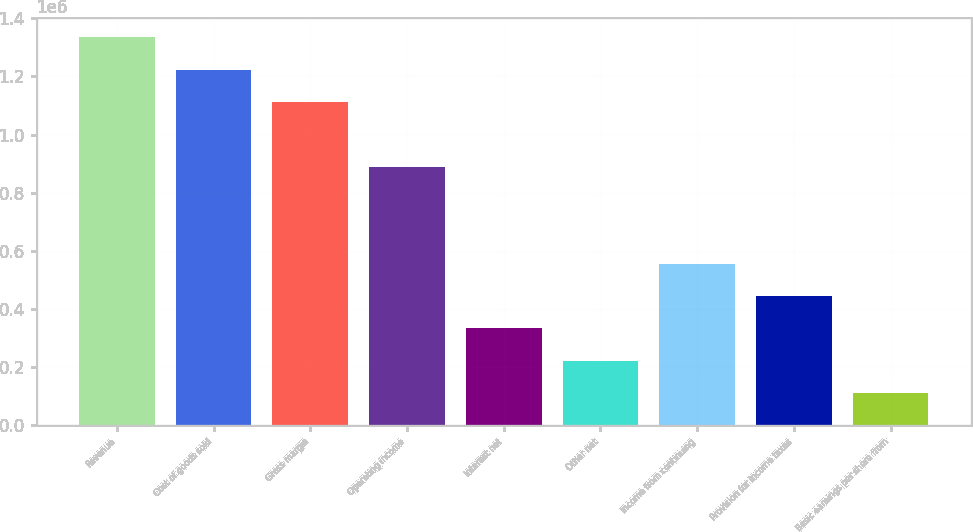Convert chart to OTSL. <chart><loc_0><loc_0><loc_500><loc_500><bar_chart><fcel>Revenue<fcel>Cost of goods sold<fcel>Gross margin<fcel>Operating income<fcel>Interest net<fcel>Other net<fcel>Income from continuing<fcel>Provision for income taxes<fcel>Basic earnings per share from<nl><fcel>1.33482e+06<fcel>1.22359e+06<fcel>1.11235e+06<fcel>889881<fcel>333706<fcel>222471<fcel>556176<fcel>444941<fcel>111236<nl></chart> 